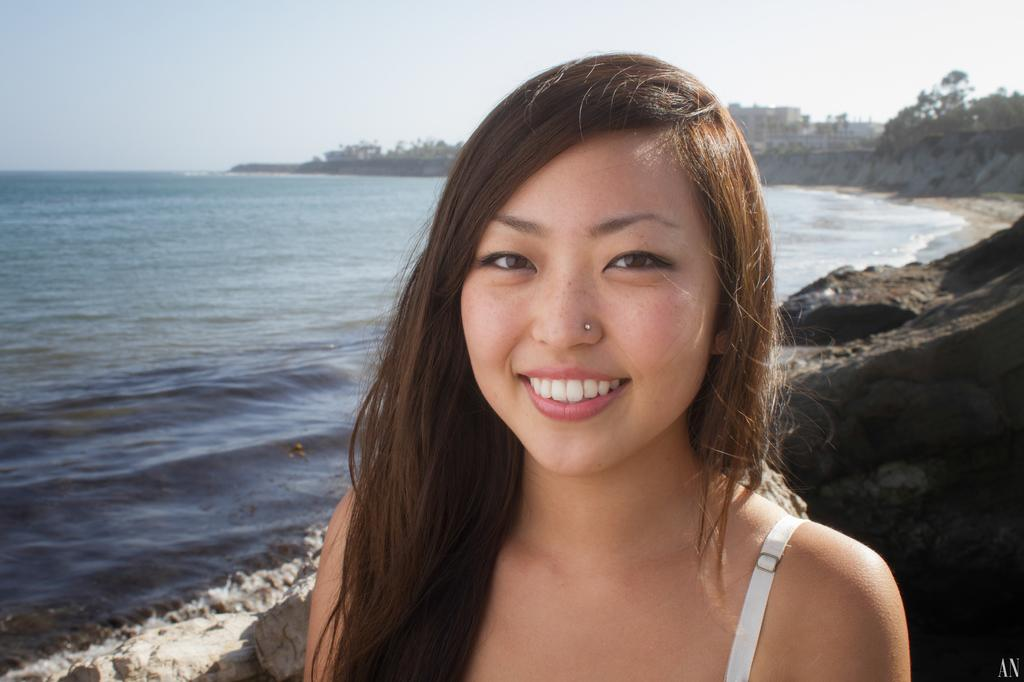Who is present in the image? There is a woman in the image. What is the woman's expression? The woman is smiling. What can be seen in the foreground of the image? There is water and rocks visible in the image. What is visible in the background of the image? The background of the image is blurry, but trees, the sky, and other objects can be seen. What type of fruit is the woman cooking in the image? There is no fruit or cooking activity present in the image. 